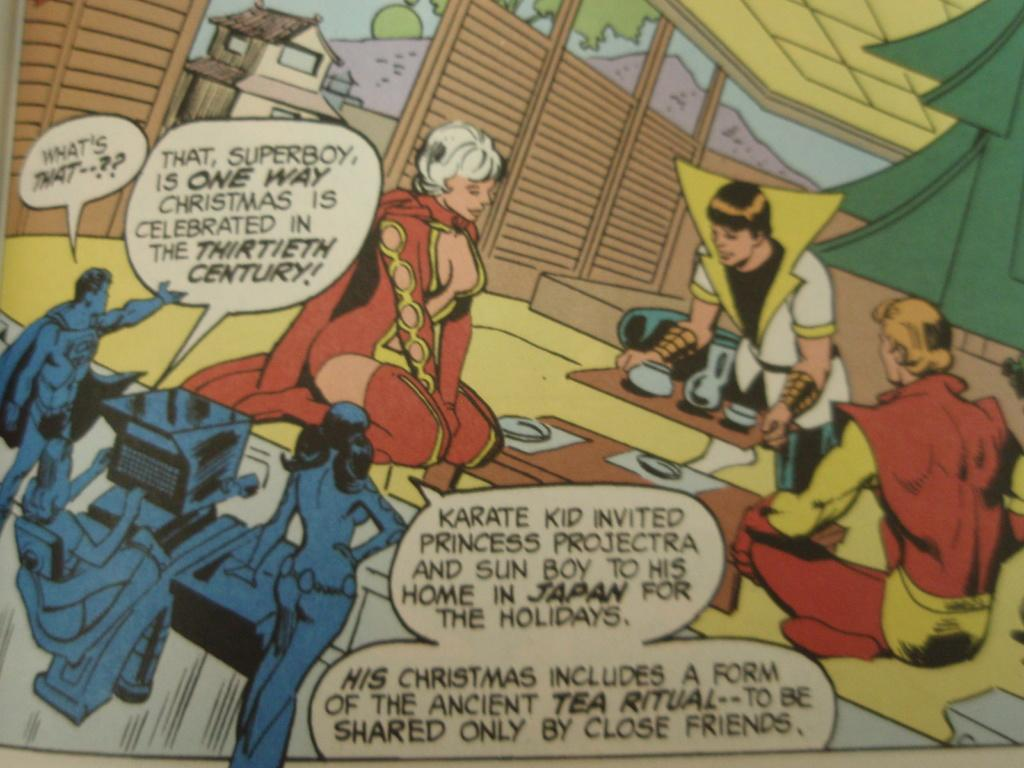<image>
Relay a brief, clear account of the picture shown. Three people are watching three other people on a monitor and Superboy is saying "What's That". 